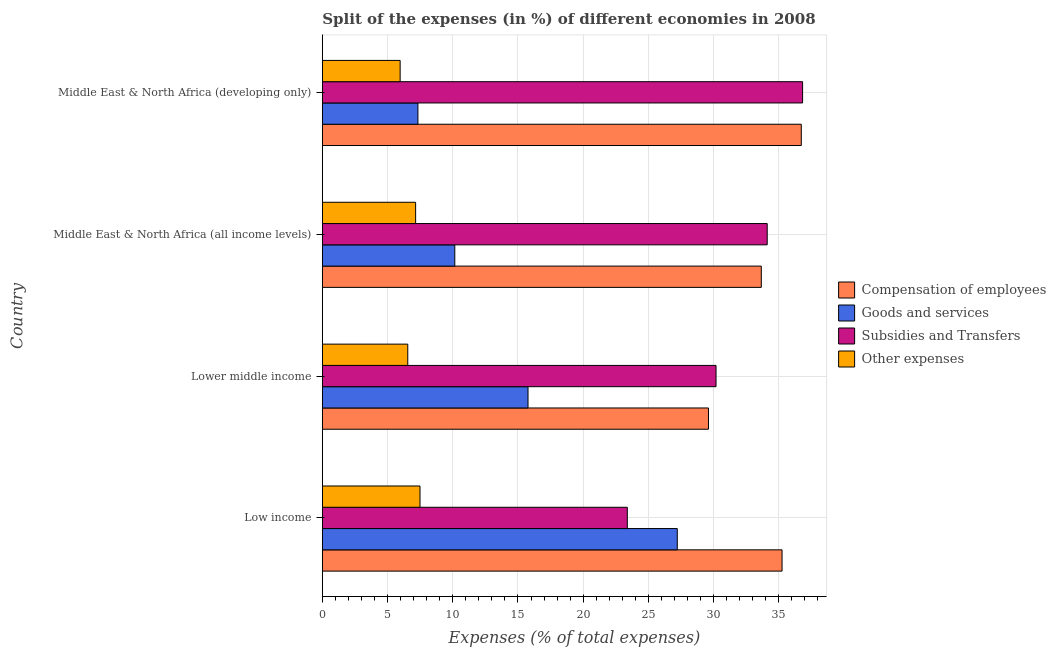Are the number of bars per tick equal to the number of legend labels?
Your response must be concise. Yes. Are the number of bars on each tick of the Y-axis equal?
Keep it short and to the point. Yes. How many bars are there on the 2nd tick from the bottom?
Keep it short and to the point. 4. What is the label of the 1st group of bars from the top?
Ensure brevity in your answer.  Middle East & North Africa (developing only). In how many cases, is the number of bars for a given country not equal to the number of legend labels?
Offer a terse response. 0. What is the percentage of amount spent on goods and services in Lower middle income?
Ensure brevity in your answer.  15.77. Across all countries, what is the maximum percentage of amount spent on compensation of employees?
Your response must be concise. 36.72. Across all countries, what is the minimum percentage of amount spent on compensation of employees?
Give a very brief answer. 29.6. In which country was the percentage of amount spent on other expenses maximum?
Give a very brief answer. Low income. In which country was the percentage of amount spent on compensation of employees minimum?
Your answer should be very brief. Lower middle income. What is the total percentage of amount spent on other expenses in the graph?
Keep it short and to the point. 27.16. What is the difference between the percentage of amount spent on goods and services in Lower middle income and that in Middle East & North Africa (developing only)?
Give a very brief answer. 8.44. What is the difference between the percentage of amount spent on other expenses in Lower middle income and the percentage of amount spent on subsidies in Middle East & North Africa (all income levels)?
Ensure brevity in your answer.  -27.56. What is the average percentage of amount spent on compensation of employees per country?
Offer a terse response. 33.81. What is the difference between the percentage of amount spent on subsidies and percentage of amount spent on compensation of employees in Middle East & North Africa (developing only)?
Give a very brief answer. 0.1. Is the difference between the percentage of amount spent on goods and services in Low income and Middle East & North Africa (developing only) greater than the difference between the percentage of amount spent on subsidies in Low income and Middle East & North Africa (developing only)?
Ensure brevity in your answer.  Yes. What is the difference between the highest and the second highest percentage of amount spent on compensation of employees?
Offer a very short reply. 1.47. What is the difference between the highest and the lowest percentage of amount spent on goods and services?
Provide a short and direct response. 19.88. In how many countries, is the percentage of amount spent on goods and services greater than the average percentage of amount spent on goods and services taken over all countries?
Make the answer very short. 2. Is the sum of the percentage of amount spent on subsidies in Middle East & North Africa (all income levels) and Middle East & North Africa (developing only) greater than the maximum percentage of amount spent on other expenses across all countries?
Ensure brevity in your answer.  Yes. Is it the case that in every country, the sum of the percentage of amount spent on compensation of employees and percentage of amount spent on subsidies is greater than the sum of percentage of amount spent on other expenses and percentage of amount spent on goods and services?
Offer a very short reply. No. What does the 2nd bar from the top in Middle East & North Africa (developing only) represents?
Offer a very short reply. Subsidies and Transfers. What does the 3rd bar from the bottom in Low income represents?
Ensure brevity in your answer.  Subsidies and Transfers. How many bars are there?
Keep it short and to the point. 16. How many countries are there in the graph?
Provide a succinct answer. 4. Are the values on the major ticks of X-axis written in scientific E-notation?
Give a very brief answer. No. Does the graph contain grids?
Your answer should be very brief. Yes. Where does the legend appear in the graph?
Offer a terse response. Center right. How are the legend labels stacked?
Your answer should be compact. Vertical. What is the title of the graph?
Your response must be concise. Split of the expenses (in %) of different economies in 2008. What is the label or title of the X-axis?
Offer a very short reply. Expenses (% of total expenses). What is the label or title of the Y-axis?
Provide a succinct answer. Country. What is the Expenses (% of total expenses) in Compensation of employees in Low income?
Offer a very short reply. 35.25. What is the Expenses (% of total expenses) of Goods and services in Low income?
Offer a terse response. 27.21. What is the Expenses (% of total expenses) of Subsidies and Transfers in Low income?
Your answer should be very brief. 23.38. What is the Expenses (% of total expenses) in Other expenses in Low income?
Ensure brevity in your answer.  7.49. What is the Expenses (% of total expenses) in Compensation of employees in Lower middle income?
Your answer should be compact. 29.6. What is the Expenses (% of total expenses) in Goods and services in Lower middle income?
Keep it short and to the point. 15.77. What is the Expenses (% of total expenses) of Subsidies and Transfers in Lower middle income?
Your answer should be compact. 30.18. What is the Expenses (% of total expenses) in Other expenses in Lower middle income?
Make the answer very short. 6.55. What is the Expenses (% of total expenses) in Compensation of employees in Middle East & North Africa (all income levels)?
Offer a terse response. 33.65. What is the Expenses (% of total expenses) in Goods and services in Middle East & North Africa (all income levels)?
Your answer should be very brief. 10.16. What is the Expenses (% of total expenses) in Subsidies and Transfers in Middle East & North Africa (all income levels)?
Your answer should be compact. 34.11. What is the Expenses (% of total expenses) of Other expenses in Middle East & North Africa (all income levels)?
Your answer should be very brief. 7.15. What is the Expenses (% of total expenses) in Compensation of employees in Middle East & North Africa (developing only)?
Keep it short and to the point. 36.72. What is the Expenses (% of total expenses) in Goods and services in Middle East & North Africa (developing only)?
Give a very brief answer. 7.33. What is the Expenses (% of total expenses) of Subsidies and Transfers in Middle East & North Africa (developing only)?
Your answer should be very brief. 36.82. What is the Expenses (% of total expenses) of Other expenses in Middle East & North Africa (developing only)?
Offer a terse response. 5.97. Across all countries, what is the maximum Expenses (% of total expenses) of Compensation of employees?
Make the answer very short. 36.72. Across all countries, what is the maximum Expenses (% of total expenses) of Goods and services?
Make the answer very short. 27.21. Across all countries, what is the maximum Expenses (% of total expenses) of Subsidies and Transfers?
Provide a succinct answer. 36.82. Across all countries, what is the maximum Expenses (% of total expenses) of Other expenses?
Your answer should be compact. 7.49. Across all countries, what is the minimum Expenses (% of total expenses) in Compensation of employees?
Ensure brevity in your answer.  29.6. Across all countries, what is the minimum Expenses (% of total expenses) in Goods and services?
Ensure brevity in your answer.  7.33. Across all countries, what is the minimum Expenses (% of total expenses) of Subsidies and Transfers?
Ensure brevity in your answer.  23.38. Across all countries, what is the minimum Expenses (% of total expenses) in Other expenses?
Give a very brief answer. 5.97. What is the total Expenses (% of total expenses) of Compensation of employees in the graph?
Ensure brevity in your answer.  135.22. What is the total Expenses (% of total expenses) in Goods and services in the graph?
Make the answer very short. 60.47. What is the total Expenses (% of total expenses) of Subsidies and Transfers in the graph?
Make the answer very short. 124.49. What is the total Expenses (% of total expenses) in Other expenses in the graph?
Offer a terse response. 27.16. What is the difference between the Expenses (% of total expenses) of Compensation of employees in Low income and that in Lower middle income?
Your answer should be compact. 5.64. What is the difference between the Expenses (% of total expenses) in Goods and services in Low income and that in Lower middle income?
Give a very brief answer. 11.44. What is the difference between the Expenses (% of total expenses) of Subsidies and Transfers in Low income and that in Lower middle income?
Make the answer very short. -6.8. What is the difference between the Expenses (% of total expenses) of Other expenses in Low income and that in Lower middle income?
Make the answer very short. 0.94. What is the difference between the Expenses (% of total expenses) in Compensation of employees in Low income and that in Middle East & North Africa (all income levels)?
Provide a short and direct response. 1.59. What is the difference between the Expenses (% of total expenses) of Goods and services in Low income and that in Middle East & North Africa (all income levels)?
Make the answer very short. 17.06. What is the difference between the Expenses (% of total expenses) of Subsidies and Transfers in Low income and that in Middle East & North Africa (all income levels)?
Keep it short and to the point. -10.73. What is the difference between the Expenses (% of total expenses) of Other expenses in Low income and that in Middle East & North Africa (all income levels)?
Make the answer very short. 0.34. What is the difference between the Expenses (% of total expenses) of Compensation of employees in Low income and that in Middle East & North Africa (developing only)?
Provide a succinct answer. -1.47. What is the difference between the Expenses (% of total expenses) of Goods and services in Low income and that in Middle East & North Africa (developing only)?
Your answer should be very brief. 19.88. What is the difference between the Expenses (% of total expenses) in Subsidies and Transfers in Low income and that in Middle East & North Africa (developing only)?
Keep it short and to the point. -13.44. What is the difference between the Expenses (% of total expenses) of Other expenses in Low income and that in Middle East & North Africa (developing only)?
Offer a very short reply. 1.52. What is the difference between the Expenses (% of total expenses) of Compensation of employees in Lower middle income and that in Middle East & North Africa (all income levels)?
Ensure brevity in your answer.  -4.05. What is the difference between the Expenses (% of total expenses) of Goods and services in Lower middle income and that in Middle East & North Africa (all income levels)?
Give a very brief answer. 5.61. What is the difference between the Expenses (% of total expenses) in Subsidies and Transfers in Lower middle income and that in Middle East & North Africa (all income levels)?
Keep it short and to the point. -3.92. What is the difference between the Expenses (% of total expenses) of Other expenses in Lower middle income and that in Middle East & North Africa (all income levels)?
Offer a terse response. -0.6. What is the difference between the Expenses (% of total expenses) of Compensation of employees in Lower middle income and that in Middle East & North Africa (developing only)?
Your answer should be very brief. -7.12. What is the difference between the Expenses (% of total expenses) in Goods and services in Lower middle income and that in Middle East & North Africa (developing only)?
Give a very brief answer. 8.44. What is the difference between the Expenses (% of total expenses) in Subsidies and Transfers in Lower middle income and that in Middle East & North Africa (developing only)?
Offer a very short reply. -6.64. What is the difference between the Expenses (% of total expenses) in Other expenses in Lower middle income and that in Middle East & North Africa (developing only)?
Your answer should be compact. 0.58. What is the difference between the Expenses (% of total expenses) of Compensation of employees in Middle East & North Africa (all income levels) and that in Middle East & North Africa (developing only)?
Provide a succinct answer. -3.07. What is the difference between the Expenses (% of total expenses) of Goods and services in Middle East & North Africa (all income levels) and that in Middle East & North Africa (developing only)?
Your answer should be very brief. 2.83. What is the difference between the Expenses (% of total expenses) in Subsidies and Transfers in Middle East & North Africa (all income levels) and that in Middle East & North Africa (developing only)?
Keep it short and to the point. -2.71. What is the difference between the Expenses (% of total expenses) in Other expenses in Middle East & North Africa (all income levels) and that in Middle East & North Africa (developing only)?
Provide a succinct answer. 1.19. What is the difference between the Expenses (% of total expenses) in Compensation of employees in Low income and the Expenses (% of total expenses) in Goods and services in Lower middle income?
Provide a succinct answer. 19.48. What is the difference between the Expenses (% of total expenses) in Compensation of employees in Low income and the Expenses (% of total expenses) in Subsidies and Transfers in Lower middle income?
Offer a terse response. 5.06. What is the difference between the Expenses (% of total expenses) of Compensation of employees in Low income and the Expenses (% of total expenses) of Other expenses in Lower middle income?
Provide a short and direct response. 28.7. What is the difference between the Expenses (% of total expenses) in Goods and services in Low income and the Expenses (% of total expenses) in Subsidies and Transfers in Lower middle income?
Your response must be concise. -2.97. What is the difference between the Expenses (% of total expenses) of Goods and services in Low income and the Expenses (% of total expenses) of Other expenses in Lower middle income?
Keep it short and to the point. 20.66. What is the difference between the Expenses (% of total expenses) in Subsidies and Transfers in Low income and the Expenses (% of total expenses) in Other expenses in Lower middle income?
Your answer should be very brief. 16.83. What is the difference between the Expenses (% of total expenses) of Compensation of employees in Low income and the Expenses (% of total expenses) of Goods and services in Middle East & North Africa (all income levels)?
Your answer should be very brief. 25.09. What is the difference between the Expenses (% of total expenses) of Compensation of employees in Low income and the Expenses (% of total expenses) of Subsidies and Transfers in Middle East & North Africa (all income levels)?
Provide a short and direct response. 1.14. What is the difference between the Expenses (% of total expenses) in Compensation of employees in Low income and the Expenses (% of total expenses) in Other expenses in Middle East & North Africa (all income levels)?
Give a very brief answer. 28.09. What is the difference between the Expenses (% of total expenses) of Goods and services in Low income and the Expenses (% of total expenses) of Subsidies and Transfers in Middle East & North Africa (all income levels)?
Ensure brevity in your answer.  -6.89. What is the difference between the Expenses (% of total expenses) in Goods and services in Low income and the Expenses (% of total expenses) in Other expenses in Middle East & North Africa (all income levels)?
Your response must be concise. 20.06. What is the difference between the Expenses (% of total expenses) in Subsidies and Transfers in Low income and the Expenses (% of total expenses) in Other expenses in Middle East & North Africa (all income levels)?
Offer a very short reply. 16.23. What is the difference between the Expenses (% of total expenses) in Compensation of employees in Low income and the Expenses (% of total expenses) in Goods and services in Middle East & North Africa (developing only)?
Your answer should be very brief. 27.92. What is the difference between the Expenses (% of total expenses) of Compensation of employees in Low income and the Expenses (% of total expenses) of Subsidies and Transfers in Middle East & North Africa (developing only)?
Make the answer very short. -1.57. What is the difference between the Expenses (% of total expenses) in Compensation of employees in Low income and the Expenses (% of total expenses) in Other expenses in Middle East & North Africa (developing only)?
Keep it short and to the point. 29.28. What is the difference between the Expenses (% of total expenses) of Goods and services in Low income and the Expenses (% of total expenses) of Subsidies and Transfers in Middle East & North Africa (developing only)?
Offer a very short reply. -9.61. What is the difference between the Expenses (% of total expenses) in Goods and services in Low income and the Expenses (% of total expenses) in Other expenses in Middle East & North Africa (developing only)?
Provide a short and direct response. 21.25. What is the difference between the Expenses (% of total expenses) in Subsidies and Transfers in Low income and the Expenses (% of total expenses) in Other expenses in Middle East & North Africa (developing only)?
Your answer should be very brief. 17.42. What is the difference between the Expenses (% of total expenses) of Compensation of employees in Lower middle income and the Expenses (% of total expenses) of Goods and services in Middle East & North Africa (all income levels)?
Ensure brevity in your answer.  19.45. What is the difference between the Expenses (% of total expenses) of Compensation of employees in Lower middle income and the Expenses (% of total expenses) of Subsidies and Transfers in Middle East & North Africa (all income levels)?
Make the answer very short. -4.5. What is the difference between the Expenses (% of total expenses) of Compensation of employees in Lower middle income and the Expenses (% of total expenses) of Other expenses in Middle East & North Africa (all income levels)?
Your answer should be compact. 22.45. What is the difference between the Expenses (% of total expenses) of Goods and services in Lower middle income and the Expenses (% of total expenses) of Subsidies and Transfers in Middle East & North Africa (all income levels)?
Keep it short and to the point. -18.34. What is the difference between the Expenses (% of total expenses) in Goods and services in Lower middle income and the Expenses (% of total expenses) in Other expenses in Middle East & North Africa (all income levels)?
Keep it short and to the point. 8.62. What is the difference between the Expenses (% of total expenses) of Subsidies and Transfers in Lower middle income and the Expenses (% of total expenses) of Other expenses in Middle East & North Africa (all income levels)?
Your answer should be compact. 23.03. What is the difference between the Expenses (% of total expenses) of Compensation of employees in Lower middle income and the Expenses (% of total expenses) of Goods and services in Middle East & North Africa (developing only)?
Provide a short and direct response. 22.28. What is the difference between the Expenses (% of total expenses) in Compensation of employees in Lower middle income and the Expenses (% of total expenses) in Subsidies and Transfers in Middle East & North Africa (developing only)?
Ensure brevity in your answer.  -7.22. What is the difference between the Expenses (% of total expenses) of Compensation of employees in Lower middle income and the Expenses (% of total expenses) of Other expenses in Middle East & North Africa (developing only)?
Make the answer very short. 23.64. What is the difference between the Expenses (% of total expenses) in Goods and services in Lower middle income and the Expenses (% of total expenses) in Subsidies and Transfers in Middle East & North Africa (developing only)?
Your answer should be very brief. -21.05. What is the difference between the Expenses (% of total expenses) in Goods and services in Lower middle income and the Expenses (% of total expenses) in Other expenses in Middle East & North Africa (developing only)?
Provide a succinct answer. 9.8. What is the difference between the Expenses (% of total expenses) in Subsidies and Transfers in Lower middle income and the Expenses (% of total expenses) in Other expenses in Middle East & North Africa (developing only)?
Your response must be concise. 24.22. What is the difference between the Expenses (% of total expenses) of Compensation of employees in Middle East & North Africa (all income levels) and the Expenses (% of total expenses) of Goods and services in Middle East & North Africa (developing only)?
Your answer should be very brief. 26.33. What is the difference between the Expenses (% of total expenses) in Compensation of employees in Middle East & North Africa (all income levels) and the Expenses (% of total expenses) in Subsidies and Transfers in Middle East & North Africa (developing only)?
Your response must be concise. -3.17. What is the difference between the Expenses (% of total expenses) in Compensation of employees in Middle East & North Africa (all income levels) and the Expenses (% of total expenses) in Other expenses in Middle East & North Africa (developing only)?
Provide a succinct answer. 27.69. What is the difference between the Expenses (% of total expenses) in Goods and services in Middle East & North Africa (all income levels) and the Expenses (% of total expenses) in Subsidies and Transfers in Middle East & North Africa (developing only)?
Provide a succinct answer. -26.66. What is the difference between the Expenses (% of total expenses) of Goods and services in Middle East & North Africa (all income levels) and the Expenses (% of total expenses) of Other expenses in Middle East & North Africa (developing only)?
Your answer should be compact. 4.19. What is the difference between the Expenses (% of total expenses) in Subsidies and Transfers in Middle East & North Africa (all income levels) and the Expenses (% of total expenses) in Other expenses in Middle East & North Africa (developing only)?
Keep it short and to the point. 28.14. What is the average Expenses (% of total expenses) of Compensation of employees per country?
Provide a short and direct response. 33.81. What is the average Expenses (% of total expenses) of Goods and services per country?
Ensure brevity in your answer.  15.12. What is the average Expenses (% of total expenses) of Subsidies and Transfers per country?
Make the answer very short. 31.12. What is the average Expenses (% of total expenses) of Other expenses per country?
Offer a very short reply. 6.79. What is the difference between the Expenses (% of total expenses) of Compensation of employees and Expenses (% of total expenses) of Goods and services in Low income?
Offer a terse response. 8.03. What is the difference between the Expenses (% of total expenses) of Compensation of employees and Expenses (% of total expenses) of Subsidies and Transfers in Low income?
Your response must be concise. 11.86. What is the difference between the Expenses (% of total expenses) in Compensation of employees and Expenses (% of total expenses) in Other expenses in Low income?
Offer a terse response. 27.76. What is the difference between the Expenses (% of total expenses) in Goods and services and Expenses (% of total expenses) in Subsidies and Transfers in Low income?
Your answer should be compact. 3.83. What is the difference between the Expenses (% of total expenses) in Goods and services and Expenses (% of total expenses) in Other expenses in Low income?
Offer a terse response. 19.72. What is the difference between the Expenses (% of total expenses) in Subsidies and Transfers and Expenses (% of total expenses) in Other expenses in Low income?
Ensure brevity in your answer.  15.89. What is the difference between the Expenses (% of total expenses) in Compensation of employees and Expenses (% of total expenses) in Goods and services in Lower middle income?
Your answer should be very brief. 13.83. What is the difference between the Expenses (% of total expenses) of Compensation of employees and Expenses (% of total expenses) of Subsidies and Transfers in Lower middle income?
Your answer should be very brief. -0.58. What is the difference between the Expenses (% of total expenses) in Compensation of employees and Expenses (% of total expenses) in Other expenses in Lower middle income?
Offer a terse response. 23.05. What is the difference between the Expenses (% of total expenses) of Goods and services and Expenses (% of total expenses) of Subsidies and Transfers in Lower middle income?
Offer a very short reply. -14.41. What is the difference between the Expenses (% of total expenses) in Goods and services and Expenses (% of total expenses) in Other expenses in Lower middle income?
Keep it short and to the point. 9.22. What is the difference between the Expenses (% of total expenses) in Subsidies and Transfers and Expenses (% of total expenses) in Other expenses in Lower middle income?
Ensure brevity in your answer.  23.63. What is the difference between the Expenses (% of total expenses) of Compensation of employees and Expenses (% of total expenses) of Goods and services in Middle East & North Africa (all income levels)?
Provide a short and direct response. 23.5. What is the difference between the Expenses (% of total expenses) in Compensation of employees and Expenses (% of total expenses) in Subsidies and Transfers in Middle East & North Africa (all income levels)?
Your answer should be very brief. -0.45. What is the difference between the Expenses (% of total expenses) of Compensation of employees and Expenses (% of total expenses) of Other expenses in Middle East & North Africa (all income levels)?
Your answer should be compact. 26.5. What is the difference between the Expenses (% of total expenses) of Goods and services and Expenses (% of total expenses) of Subsidies and Transfers in Middle East & North Africa (all income levels)?
Give a very brief answer. -23.95. What is the difference between the Expenses (% of total expenses) of Goods and services and Expenses (% of total expenses) of Other expenses in Middle East & North Africa (all income levels)?
Your response must be concise. 3. What is the difference between the Expenses (% of total expenses) in Subsidies and Transfers and Expenses (% of total expenses) in Other expenses in Middle East & North Africa (all income levels)?
Keep it short and to the point. 26.95. What is the difference between the Expenses (% of total expenses) of Compensation of employees and Expenses (% of total expenses) of Goods and services in Middle East & North Africa (developing only)?
Your answer should be compact. 29.39. What is the difference between the Expenses (% of total expenses) of Compensation of employees and Expenses (% of total expenses) of Subsidies and Transfers in Middle East & North Africa (developing only)?
Your answer should be compact. -0.1. What is the difference between the Expenses (% of total expenses) of Compensation of employees and Expenses (% of total expenses) of Other expenses in Middle East & North Africa (developing only)?
Offer a very short reply. 30.75. What is the difference between the Expenses (% of total expenses) in Goods and services and Expenses (% of total expenses) in Subsidies and Transfers in Middle East & North Africa (developing only)?
Your answer should be compact. -29.49. What is the difference between the Expenses (% of total expenses) of Goods and services and Expenses (% of total expenses) of Other expenses in Middle East & North Africa (developing only)?
Offer a terse response. 1.36. What is the difference between the Expenses (% of total expenses) of Subsidies and Transfers and Expenses (% of total expenses) of Other expenses in Middle East & North Africa (developing only)?
Your answer should be very brief. 30.85. What is the ratio of the Expenses (% of total expenses) of Compensation of employees in Low income to that in Lower middle income?
Provide a short and direct response. 1.19. What is the ratio of the Expenses (% of total expenses) in Goods and services in Low income to that in Lower middle income?
Your response must be concise. 1.73. What is the ratio of the Expenses (% of total expenses) of Subsidies and Transfers in Low income to that in Lower middle income?
Keep it short and to the point. 0.77. What is the ratio of the Expenses (% of total expenses) of Other expenses in Low income to that in Lower middle income?
Give a very brief answer. 1.14. What is the ratio of the Expenses (% of total expenses) of Compensation of employees in Low income to that in Middle East & North Africa (all income levels)?
Give a very brief answer. 1.05. What is the ratio of the Expenses (% of total expenses) of Goods and services in Low income to that in Middle East & North Africa (all income levels)?
Offer a very short reply. 2.68. What is the ratio of the Expenses (% of total expenses) in Subsidies and Transfers in Low income to that in Middle East & North Africa (all income levels)?
Provide a short and direct response. 0.69. What is the ratio of the Expenses (% of total expenses) in Other expenses in Low income to that in Middle East & North Africa (all income levels)?
Your response must be concise. 1.05. What is the ratio of the Expenses (% of total expenses) of Compensation of employees in Low income to that in Middle East & North Africa (developing only)?
Keep it short and to the point. 0.96. What is the ratio of the Expenses (% of total expenses) in Goods and services in Low income to that in Middle East & North Africa (developing only)?
Your answer should be very brief. 3.71. What is the ratio of the Expenses (% of total expenses) of Subsidies and Transfers in Low income to that in Middle East & North Africa (developing only)?
Provide a short and direct response. 0.64. What is the ratio of the Expenses (% of total expenses) of Other expenses in Low income to that in Middle East & North Africa (developing only)?
Keep it short and to the point. 1.26. What is the ratio of the Expenses (% of total expenses) of Compensation of employees in Lower middle income to that in Middle East & North Africa (all income levels)?
Offer a very short reply. 0.88. What is the ratio of the Expenses (% of total expenses) of Goods and services in Lower middle income to that in Middle East & North Africa (all income levels)?
Give a very brief answer. 1.55. What is the ratio of the Expenses (% of total expenses) of Subsidies and Transfers in Lower middle income to that in Middle East & North Africa (all income levels)?
Ensure brevity in your answer.  0.89. What is the ratio of the Expenses (% of total expenses) in Other expenses in Lower middle income to that in Middle East & North Africa (all income levels)?
Your answer should be compact. 0.92. What is the ratio of the Expenses (% of total expenses) of Compensation of employees in Lower middle income to that in Middle East & North Africa (developing only)?
Provide a short and direct response. 0.81. What is the ratio of the Expenses (% of total expenses) in Goods and services in Lower middle income to that in Middle East & North Africa (developing only)?
Your answer should be very brief. 2.15. What is the ratio of the Expenses (% of total expenses) of Subsidies and Transfers in Lower middle income to that in Middle East & North Africa (developing only)?
Keep it short and to the point. 0.82. What is the ratio of the Expenses (% of total expenses) of Other expenses in Lower middle income to that in Middle East & North Africa (developing only)?
Your answer should be compact. 1.1. What is the ratio of the Expenses (% of total expenses) in Compensation of employees in Middle East & North Africa (all income levels) to that in Middle East & North Africa (developing only)?
Keep it short and to the point. 0.92. What is the ratio of the Expenses (% of total expenses) of Goods and services in Middle East & North Africa (all income levels) to that in Middle East & North Africa (developing only)?
Offer a terse response. 1.39. What is the ratio of the Expenses (% of total expenses) of Subsidies and Transfers in Middle East & North Africa (all income levels) to that in Middle East & North Africa (developing only)?
Make the answer very short. 0.93. What is the ratio of the Expenses (% of total expenses) in Other expenses in Middle East & North Africa (all income levels) to that in Middle East & North Africa (developing only)?
Your response must be concise. 1.2. What is the difference between the highest and the second highest Expenses (% of total expenses) in Compensation of employees?
Provide a succinct answer. 1.47. What is the difference between the highest and the second highest Expenses (% of total expenses) of Goods and services?
Offer a very short reply. 11.44. What is the difference between the highest and the second highest Expenses (% of total expenses) in Subsidies and Transfers?
Give a very brief answer. 2.71. What is the difference between the highest and the second highest Expenses (% of total expenses) of Other expenses?
Offer a terse response. 0.34. What is the difference between the highest and the lowest Expenses (% of total expenses) in Compensation of employees?
Offer a terse response. 7.12. What is the difference between the highest and the lowest Expenses (% of total expenses) in Goods and services?
Make the answer very short. 19.88. What is the difference between the highest and the lowest Expenses (% of total expenses) of Subsidies and Transfers?
Provide a short and direct response. 13.44. What is the difference between the highest and the lowest Expenses (% of total expenses) of Other expenses?
Keep it short and to the point. 1.52. 